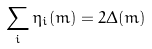Convert formula to latex. <formula><loc_0><loc_0><loc_500><loc_500>\sum _ { i } \eta _ { i } ( { m } ) = 2 \Delta ( { m } )</formula> 